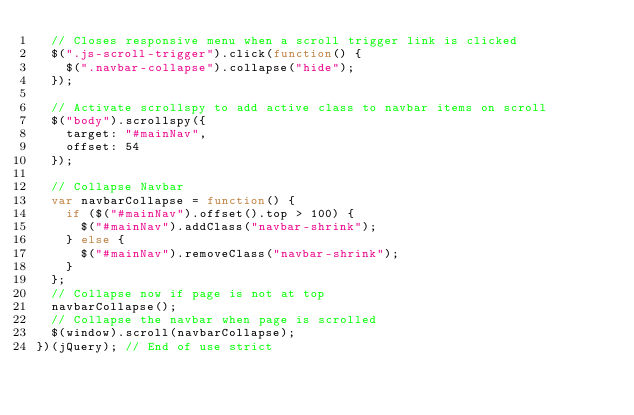<code> <loc_0><loc_0><loc_500><loc_500><_JavaScript_>  // Closes responsive menu when a scroll trigger link is clicked
  $(".js-scroll-trigger").click(function() {
    $(".navbar-collapse").collapse("hide");
  });

  // Activate scrollspy to add active class to navbar items on scroll
  $("body").scrollspy({
    target: "#mainNav",
    offset: 54
  });

  // Collapse Navbar
  var navbarCollapse = function() {
    if ($("#mainNav").offset().top > 100) {
      $("#mainNav").addClass("navbar-shrink");
    } else {
      $("#mainNav").removeClass("navbar-shrink");
    }
  };
  // Collapse now if page is not at top
  navbarCollapse();
  // Collapse the navbar when page is scrolled
  $(window).scroll(navbarCollapse);
})(jQuery); // End of use strict
</code> 